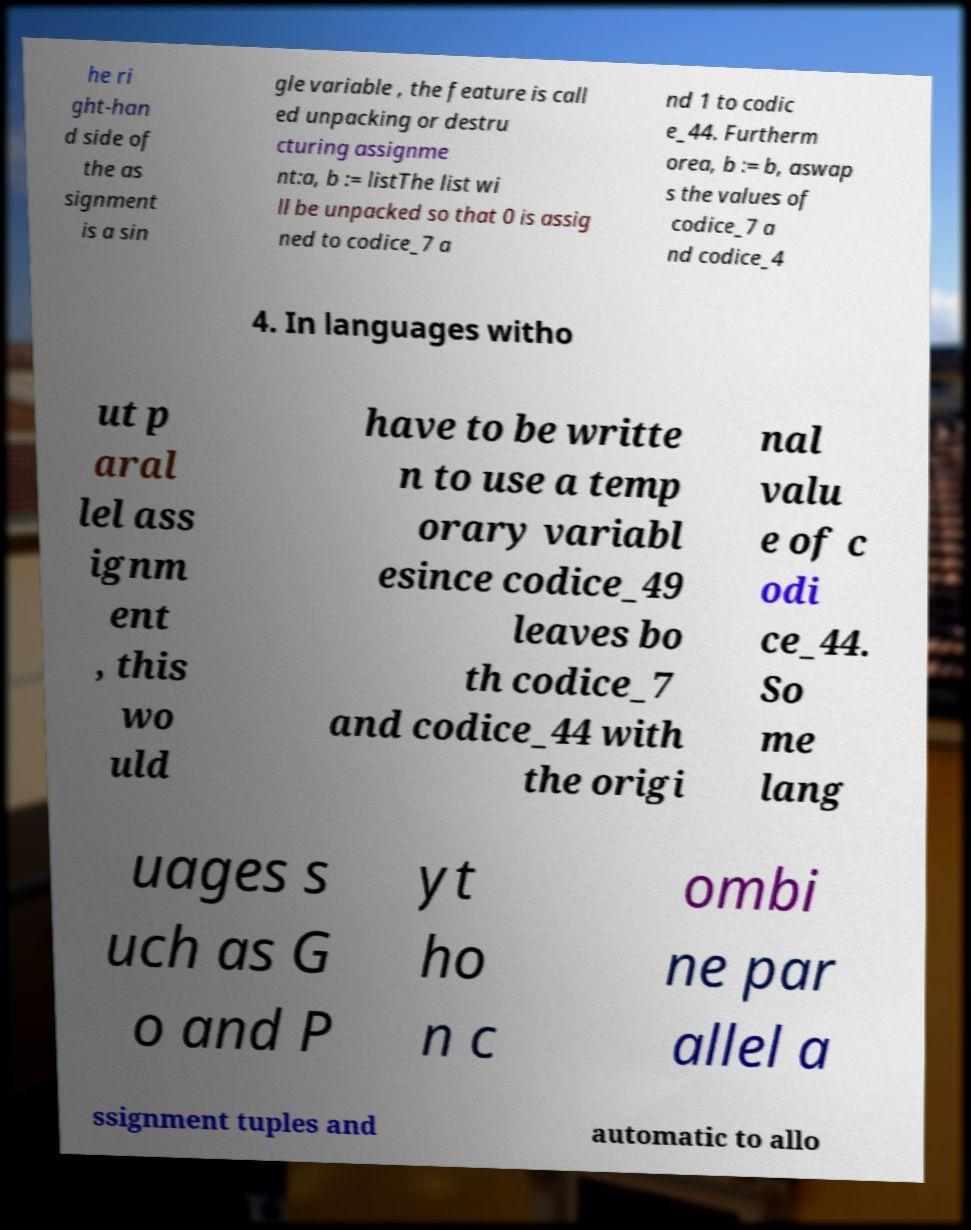Could you assist in decoding the text presented in this image and type it out clearly? he ri ght-han d side of the as signment is a sin gle variable , the feature is call ed unpacking or destru cturing assignme nt:a, b := listThe list wi ll be unpacked so that 0 is assig ned to codice_7 a nd 1 to codic e_44. Furtherm orea, b := b, aswap s the values of codice_7 a nd codice_4 4. In languages witho ut p aral lel ass ignm ent , this wo uld have to be writte n to use a temp orary variabl esince codice_49 leaves bo th codice_7 and codice_44 with the origi nal valu e of c odi ce_44. So me lang uages s uch as G o and P yt ho n c ombi ne par allel a ssignment tuples and automatic to allo 